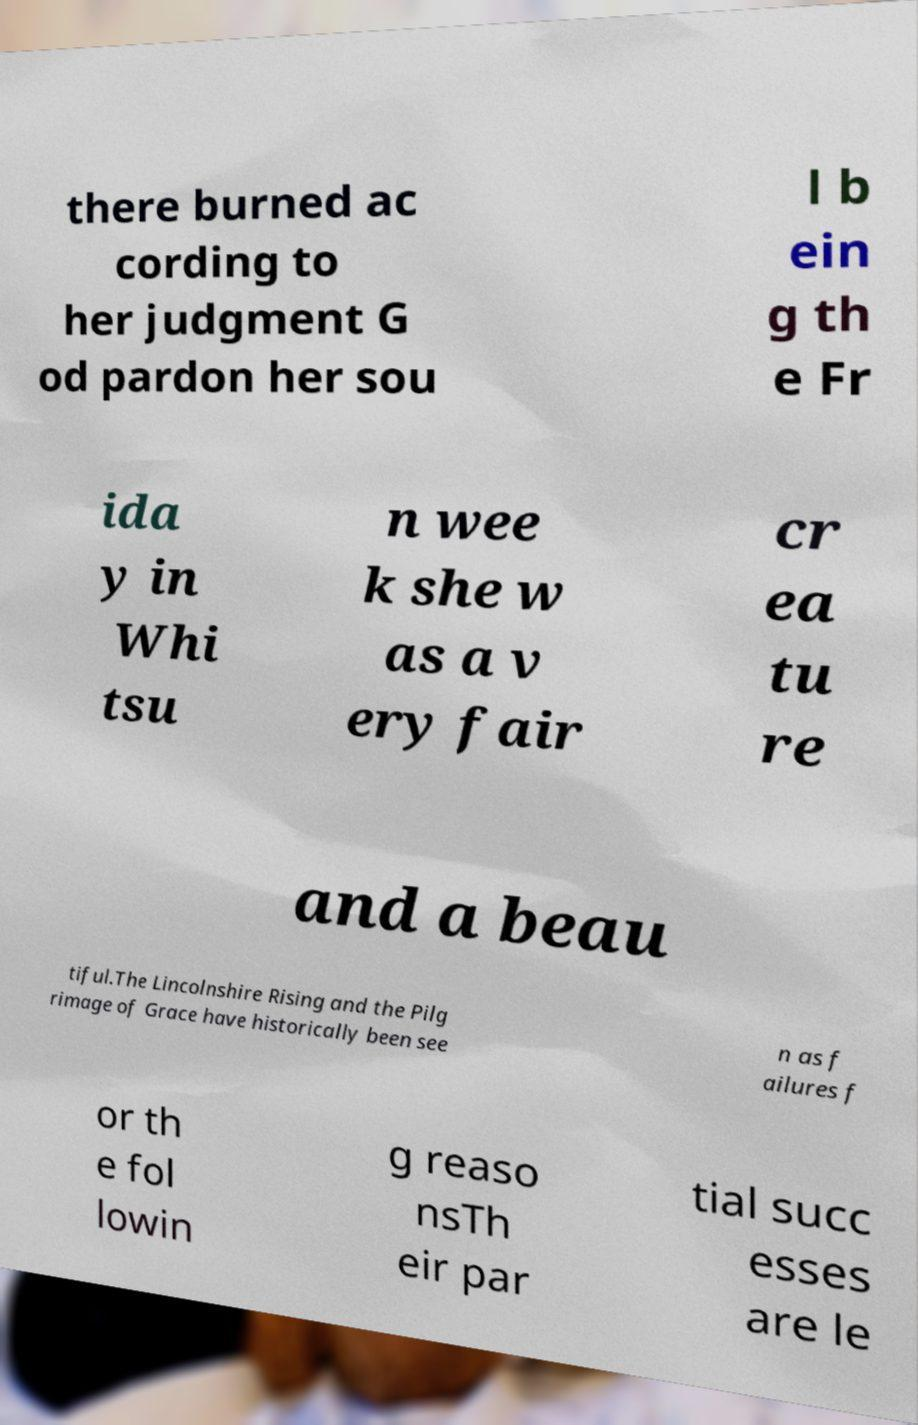For documentation purposes, I need the text within this image transcribed. Could you provide that? there burned ac cording to her judgment G od pardon her sou l b ein g th e Fr ida y in Whi tsu n wee k she w as a v ery fair cr ea tu re and a beau tiful.The Lincolnshire Rising and the Pilg rimage of Grace have historically been see n as f ailures f or th e fol lowin g reaso nsTh eir par tial succ esses are le 